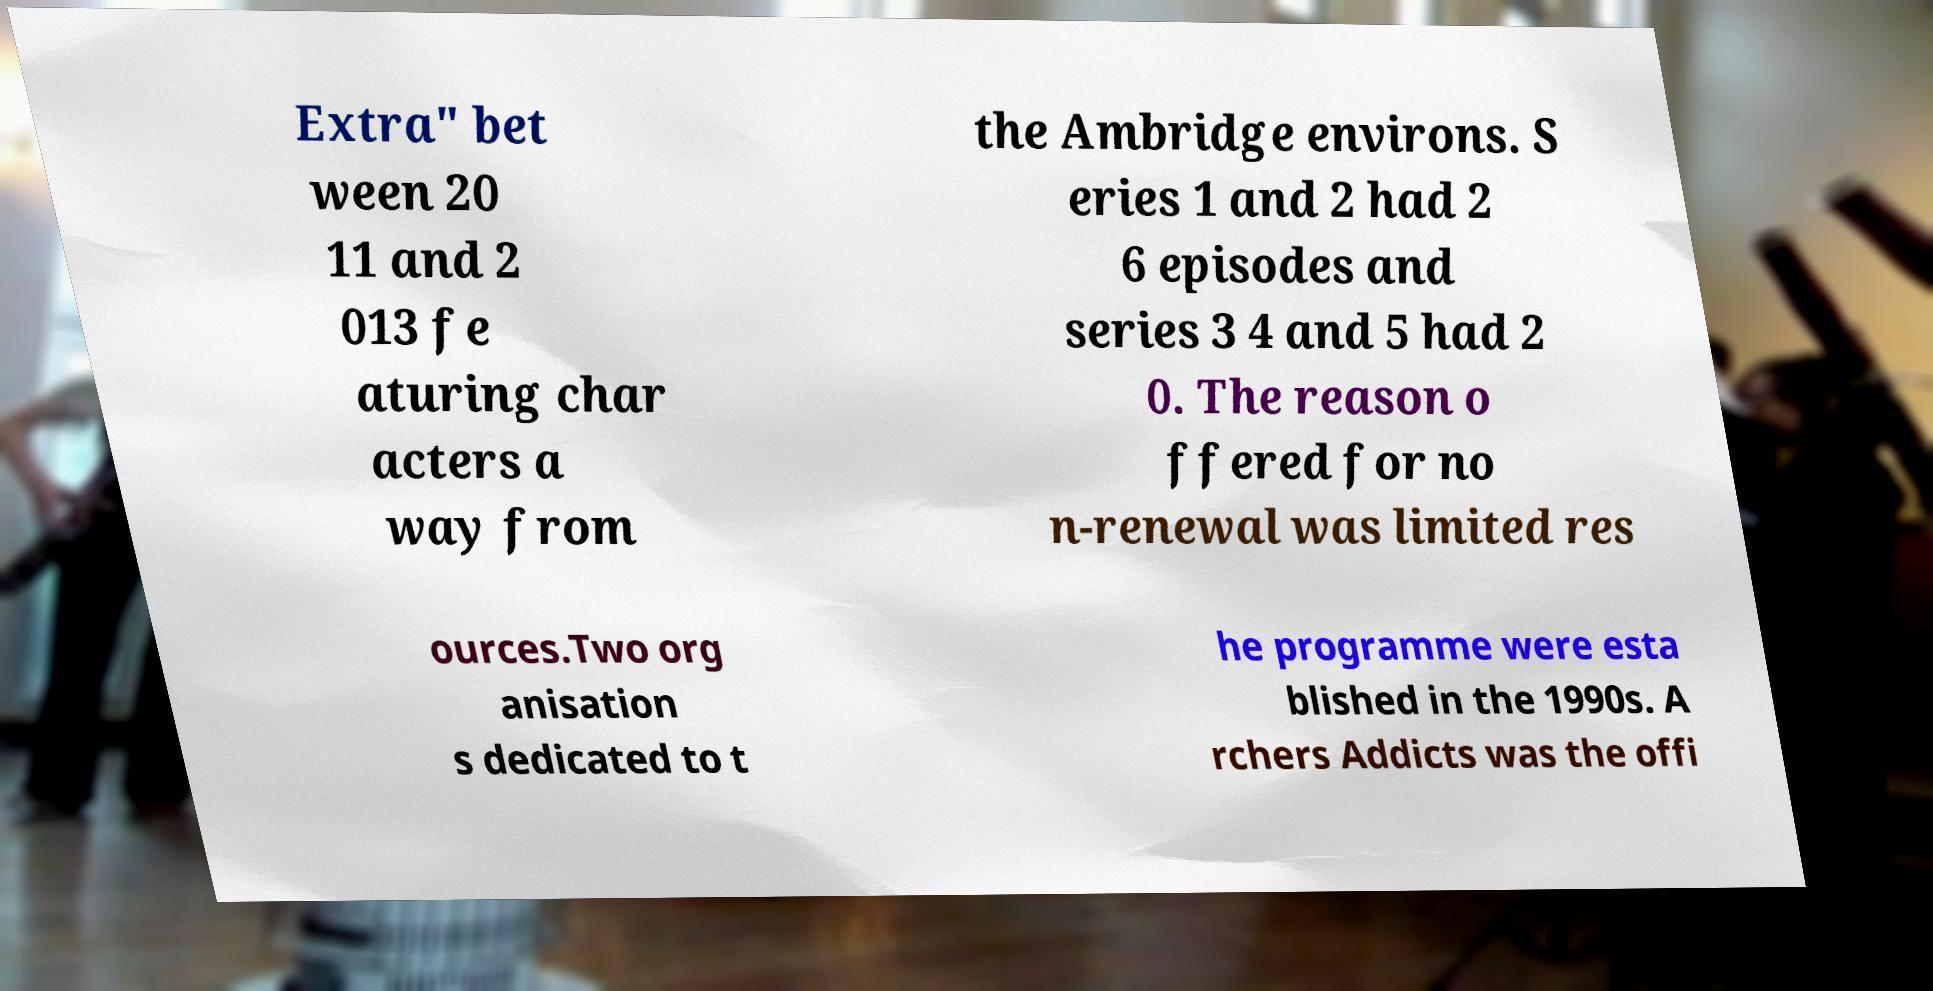Could you extract and type out the text from this image? Extra" bet ween 20 11 and 2 013 fe aturing char acters a way from the Ambridge environs. S eries 1 and 2 had 2 6 episodes and series 3 4 and 5 had 2 0. The reason o ffered for no n-renewal was limited res ources.Two org anisation s dedicated to t he programme were esta blished in the 1990s. A rchers Addicts was the offi 